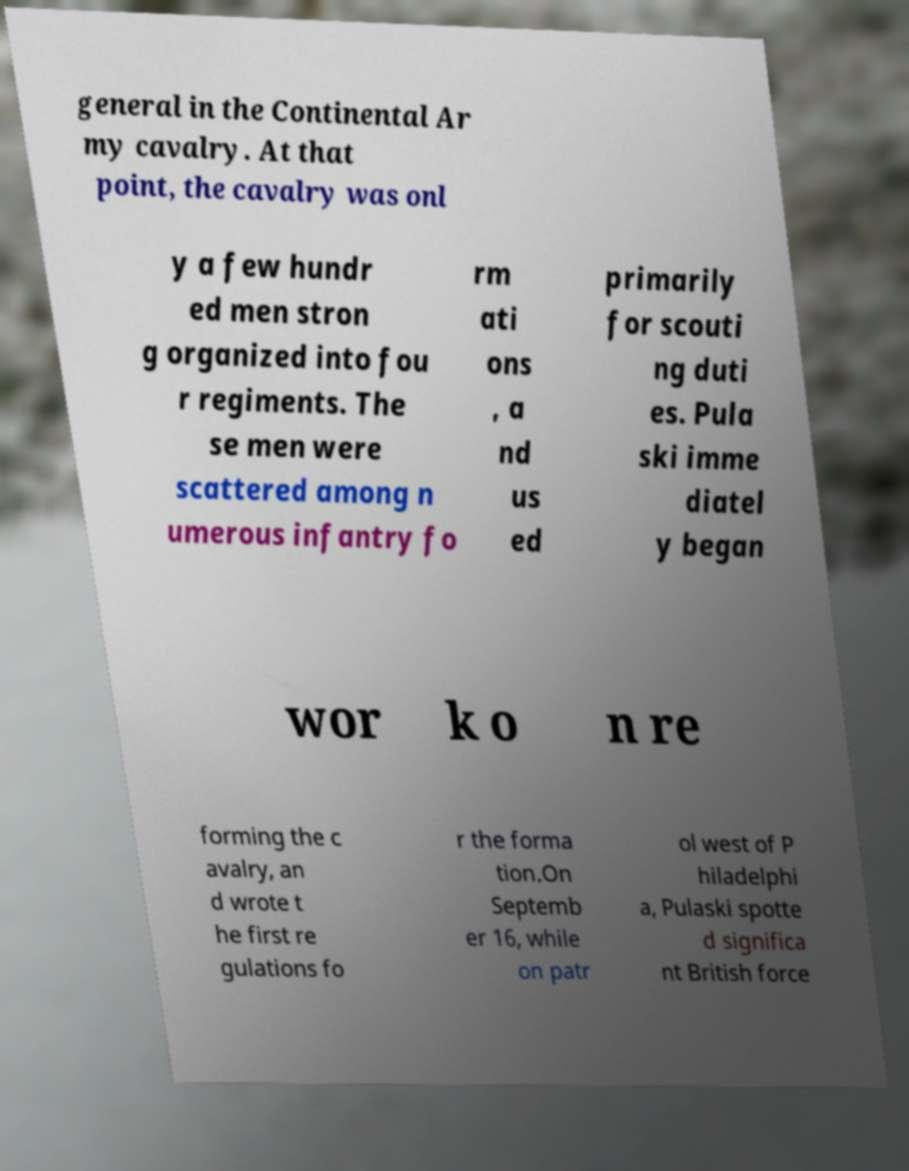Please identify and transcribe the text found in this image. general in the Continental Ar my cavalry. At that point, the cavalry was onl y a few hundr ed men stron g organized into fou r regiments. The se men were scattered among n umerous infantry fo rm ati ons , a nd us ed primarily for scouti ng duti es. Pula ski imme diatel y began wor k o n re forming the c avalry, an d wrote t he first re gulations fo r the forma tion.On Septemb er 16, while on patr ol west of P hiladelphi a, Pulaski spotte d significa nt British force 